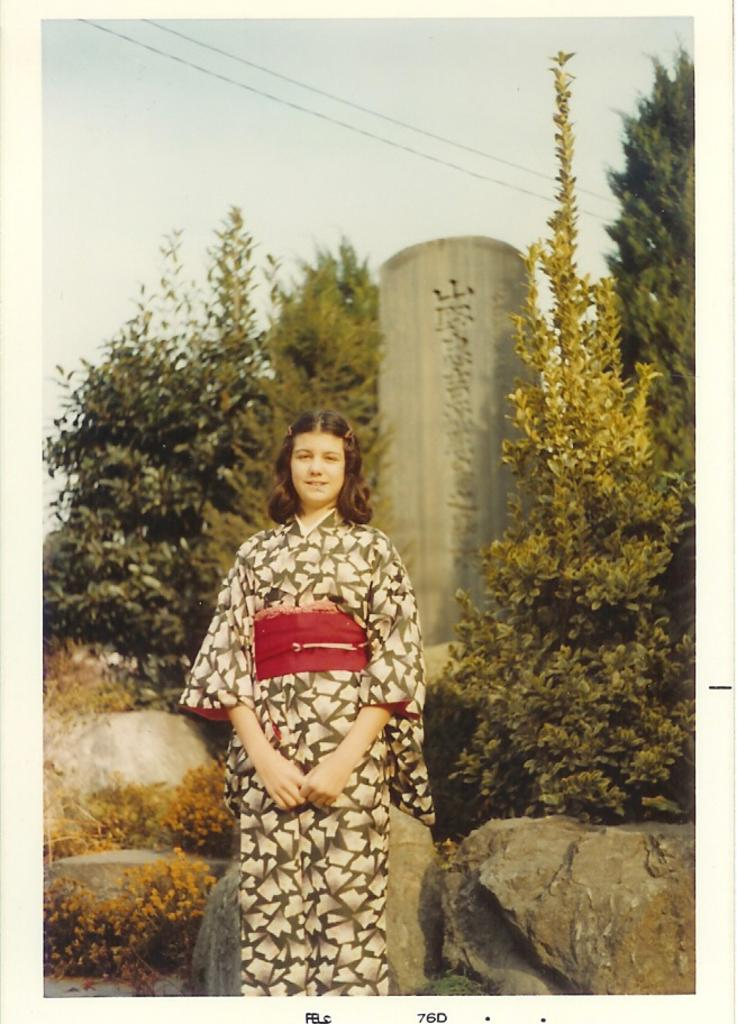What is the main subject of the image? There is a person standing in the image. What can be seen in the background of the image? There are trees, wires, and the sky visible in the background of the image. What structure is present in the image? There is a tower in the image. What type of terrain is at the bottom of the image? There are rocks at the bottom of the image. What type of test is being conducted in the image? There is no indication of a test being conducted in the image. Can you tell me when the person's birthday is in the image? There is no information about the person's birthday in the image. 